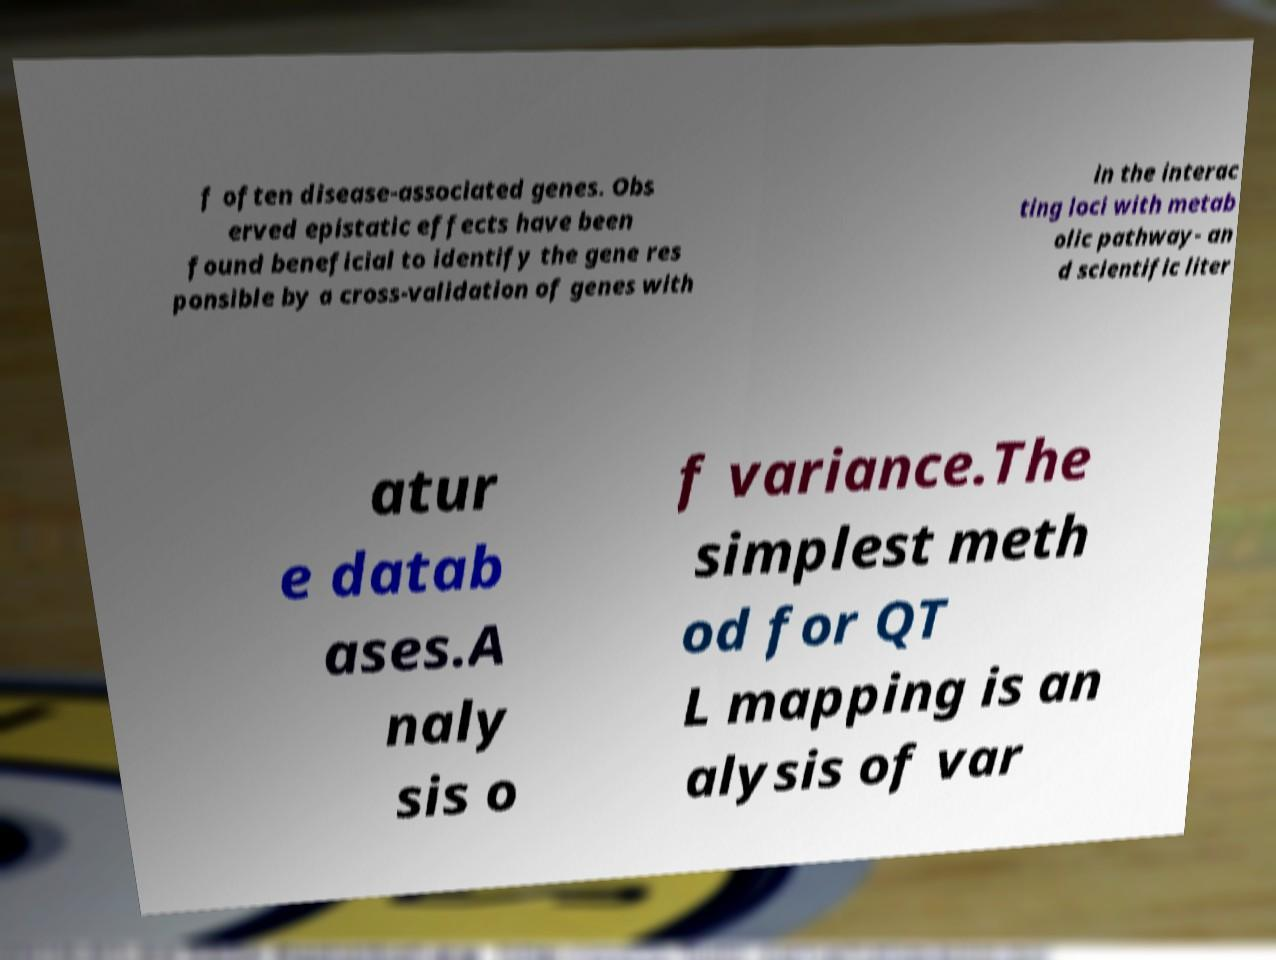Please read and relay the text visible in this image. What does it say? f often disease-associated genes. Obs erved epistatic effects have been found beneficial to identify the gene res ponsible by a cross-validation of genes with in the interac ting loci with metab olic pathway- an d scientific liter atur e datab ases.A naly sis o f variance.The simplest meth od for QT L mapping is an alysis of var 